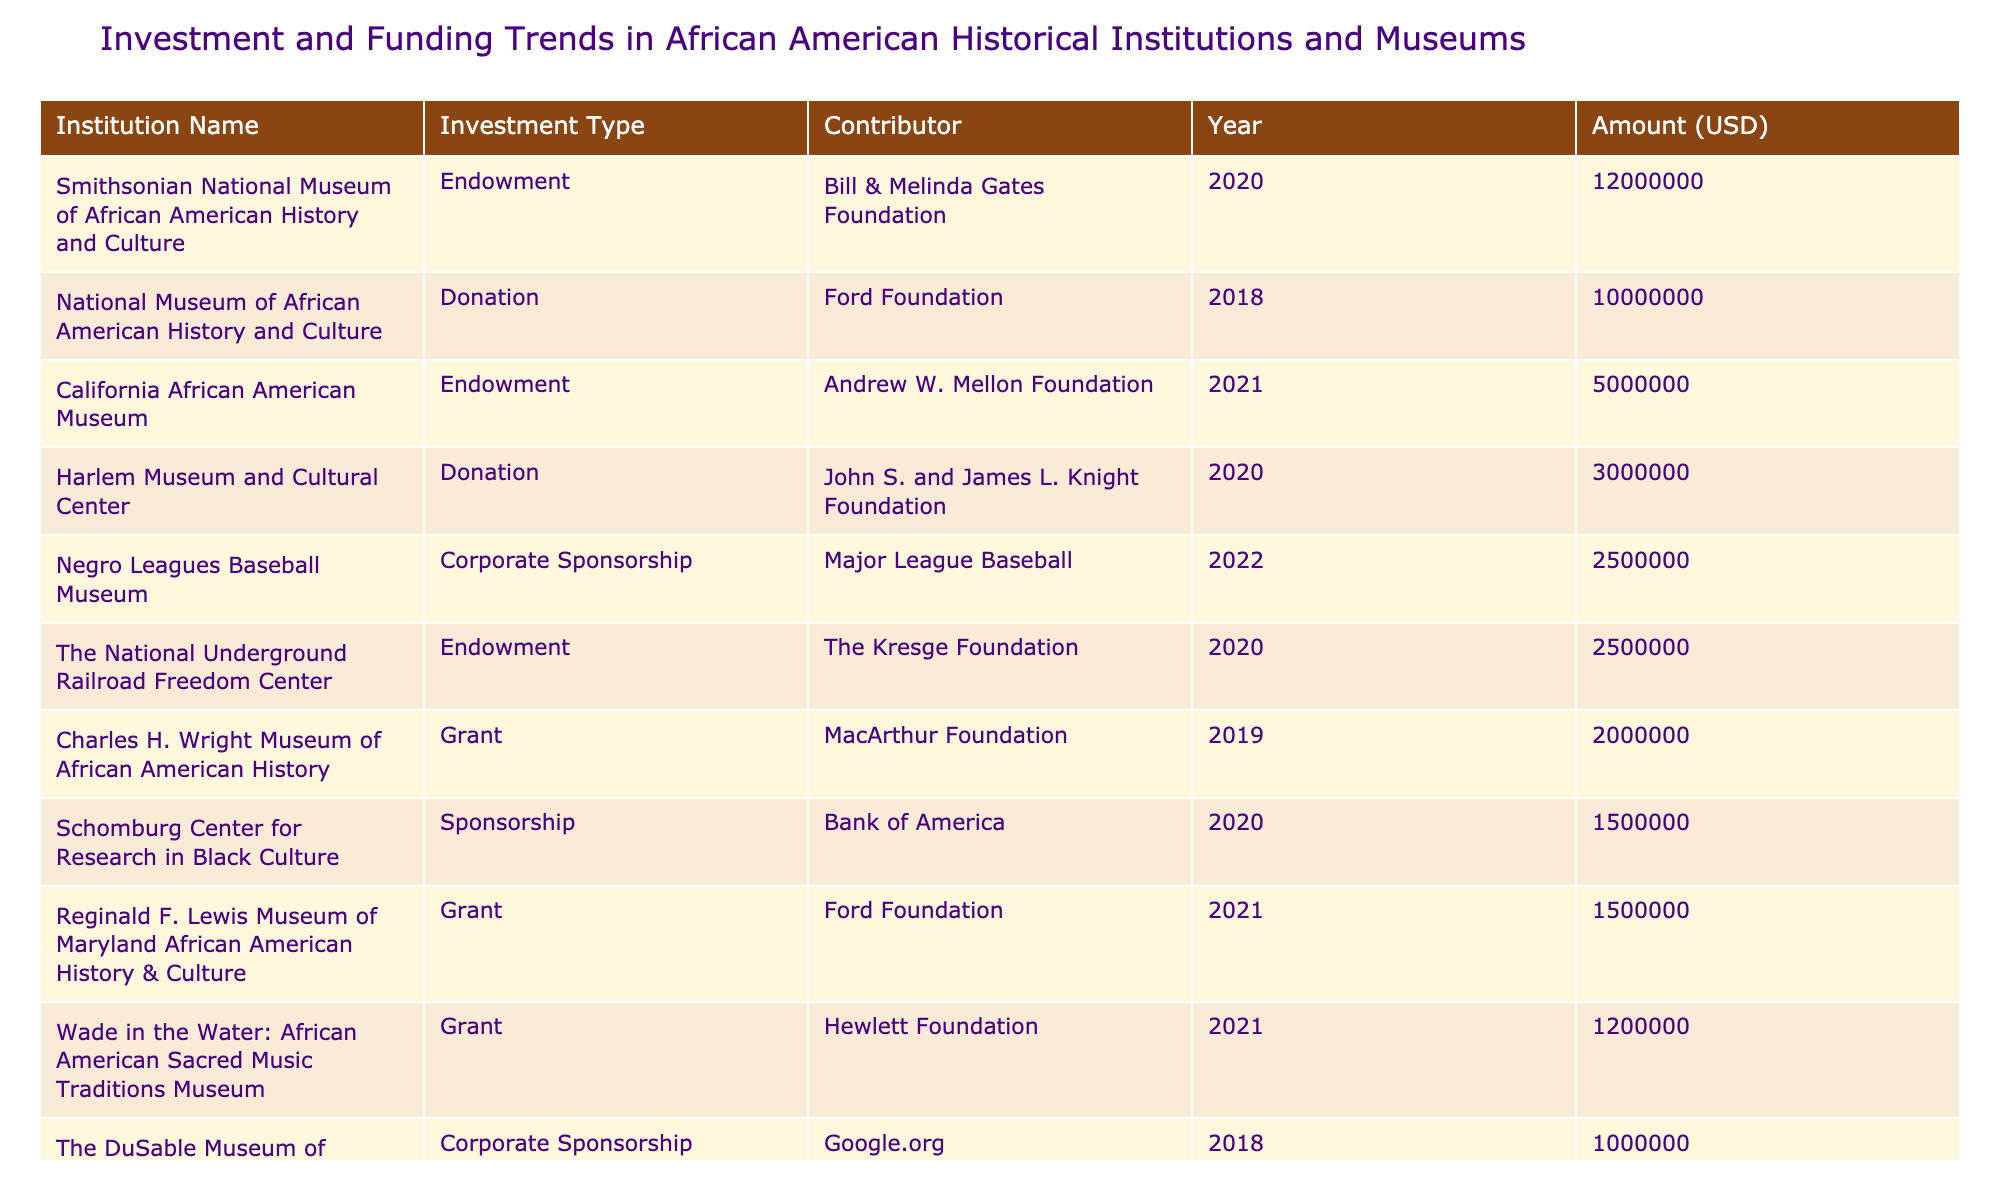What was the largest single amount donated among the institutions listed? The table shows several donations, and the largest one is by the Ford Foundation to the National Museum of African American History and Culture for 10,000,000 USD in 2018.
Answer: 10,000,000 USD Which institution received government funding in 2019? According to the table, the Jackie Robinson Museum received government funding from the National Endowment for the Humanities in 2019, amounting to 800,000 USD.
Answer: Jackie Robinson Museum What is the total amount of funding received by the Schomburg Center for Research in Black Culture? The Schomburg Center received 1,500,000 USD from Bank of America in 2020, which is the only entry for this institution. Therefore, the total funding amount is 1,500,000 USD.
Answer: 1,500,000 USD How much more funding did the Smithsonian National Museum of African American History and Culture receive compared to the Charles H. Wright Museum of African American History? The Smithsonian National Museum received 12,000,000 USD, while the Charles H. Wright Museum received 2,000,000 USD. The difference is 12,000,000 - 2,000,000 = 10,000,000 USD.
Answer: 10,000,000 USD Did any institution receive an endowment in 2021? According to the table, the California African American Museum received an endowment from the Andrew W. Mellon Foundation in 2021. Therefore, the statement is true.
Answer: Yes Which funding contributor contributed the least amount to any institution? The table shows that the Institute of Museum and Library Services contributed 400,000 USD to the Freedom Rides Museum in 2021, which is the lowest amount listed.
Answer: 400,000 USD What percentage of the total funding was contributed by the Bill & Melinda Gates Foundation? The Bill & Melinda Gates Foundation contributed 12,000,000 USD to the Smithsonian National Museum of African American History and Culture. To find the percentage, we first sum all amounts in the table, which totals 36,300,000 USD. The percentage is (12,000,000 / 36,300,000) * 100, which is approximately 33.0%.
Answer: 33.0% Which institution listed had the highest amount funded through corporate sponsorship? The Negro Leagues Baseball Museum received 2,500,000 USD through corporate sponsorship from Major League Baseball in 2022, making it the highest corporate sponsorship amount listed in the table.
Answer: Negro Leagues Baseball Museum 